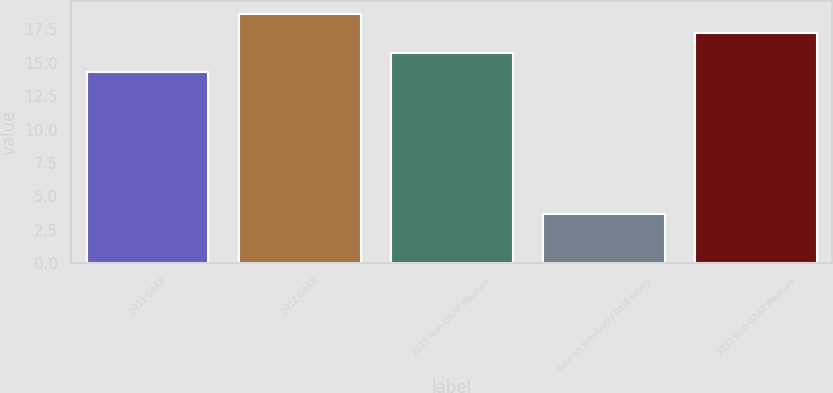<chart> <loc_0><loc_0><loc_500><loc_500><bar_chart><fcel>2013 GAAP<fcel>2012 GAAP<fcel>2013 Non-GAAP Measure<fcel>Gain on previously held equity<fcel>2012 Non-GAAP Measure<nl><fcel>14.3<fcel>18.68<fcel>15.76<fcel>3.7<fcel>17.22<nl></chart> 